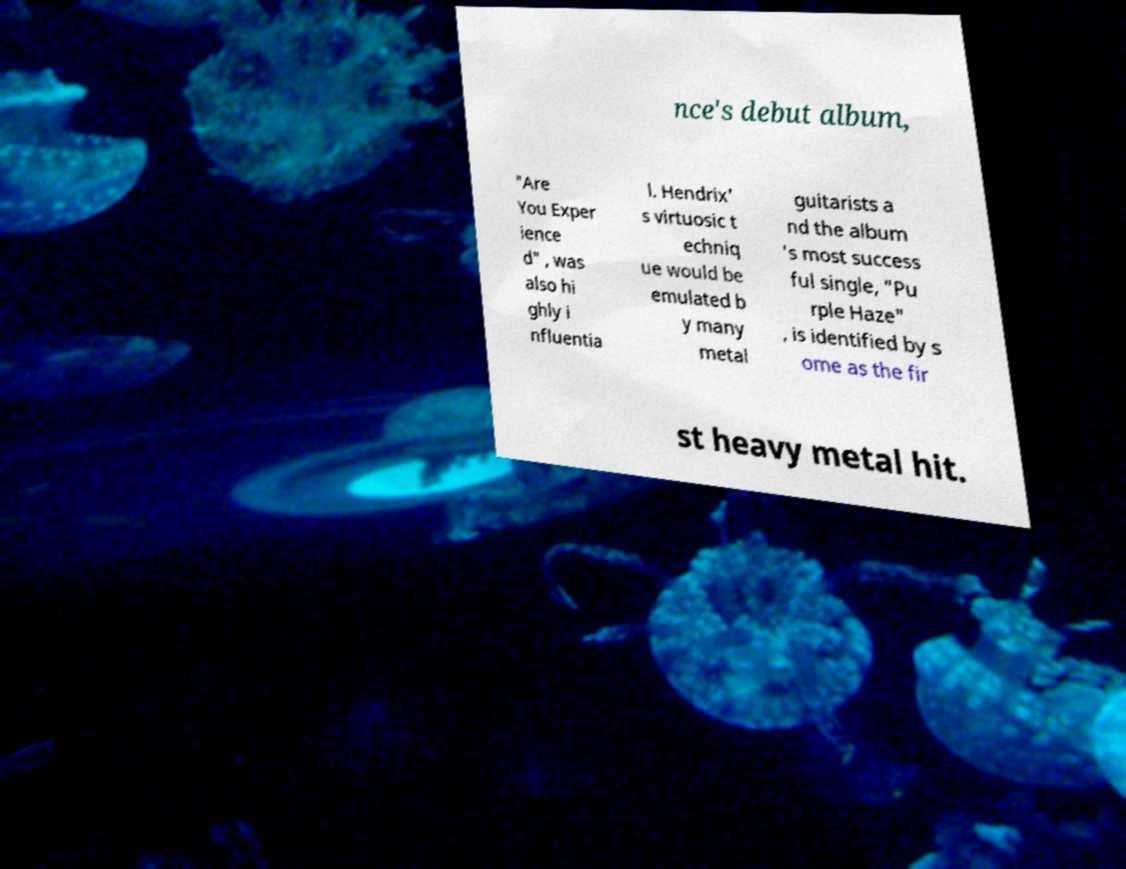There's text embedded in this image that I need extracted. Can you transcribe it verbatim? nce's debut album, "Are You Exper ience d" , was also hi ghly i nfluentia l. Hendrix' s virtuosic t echniq ue would be emulated b y many metal guitarists a nd the album 's most success ful single, "Pu rple Haze" , is identified by s ome as the fir st heavy metal hit. 